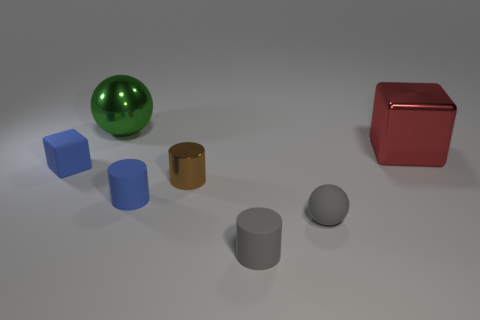What number of brown things are in front of the matte cylinder to the left of the shiny object that is in front of the tiny block?
Provide a succinct answer. 0. How many spheres are in front of the tiny blue matte cube and behind the tiny metal object?
Ensure brevity in your answer.  0. Is the number of blocks that are right of the green thing greater than the number of big red metallic spheres?
Keep it short and to the point. Yes. What number of rubber objects are the same size as the gray rubber ball?
Keep it short and to the point. 3. What size is the cylinder that is the same color as the tiny matte block?
Provide a short and direct response. Small. How many big objects are purple metal balls or cylinders?
Keep it short and to the point. 0. What number of large green balls are there?
Provide a short and direct response. 1. Is the number of metallic cylinders to the left of the brown thing the same as the number of small objects left of the small rubber ball?
Your response must be concise. No. There is a small blue cylinder; are there any tiny matte objects in front of it?
Make the answer very short. Yes. There is a tiny rubber thing left of the large green thing; what color is it?
Your response must be concise. Blue. 